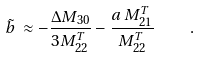<formula> <loc_0><loc_0><loc_500><loc_500>\tilde { b } \, \approx - \frac { \Delta M _ { 3 0 } } { 3 M _ { 2 2 } ^ { T } } - \frac { a \, M _ { 2 1 } ^ { T } } { M _ { 2 2 } ^ { T } } \quad .</formula> 